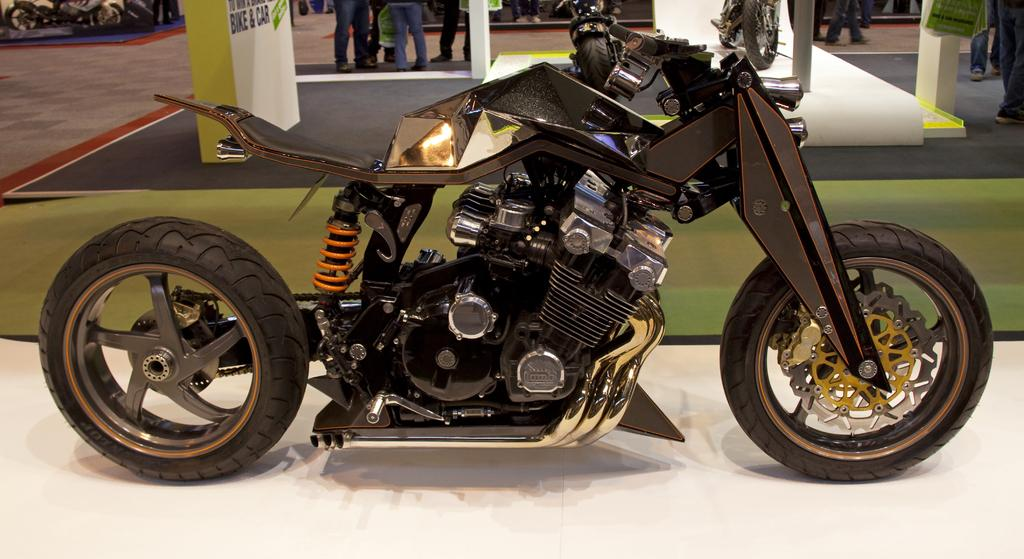What type of vehicles are in the image? There are motorcycles in the image. What else can be seen in the image besides the motorcycles? There are people standing in the image. What is the purpose of the board with text visible in the image? The purpose of the board with text is not clear from the image, but it might be providing information or instructions. What type of bit is being used by the people in the image? There is no bit visible in the image, as it features motorcycles and people standing. How are the people using the guide in the image? There is no guide present in the image, as it features motorcycles and people standing. 